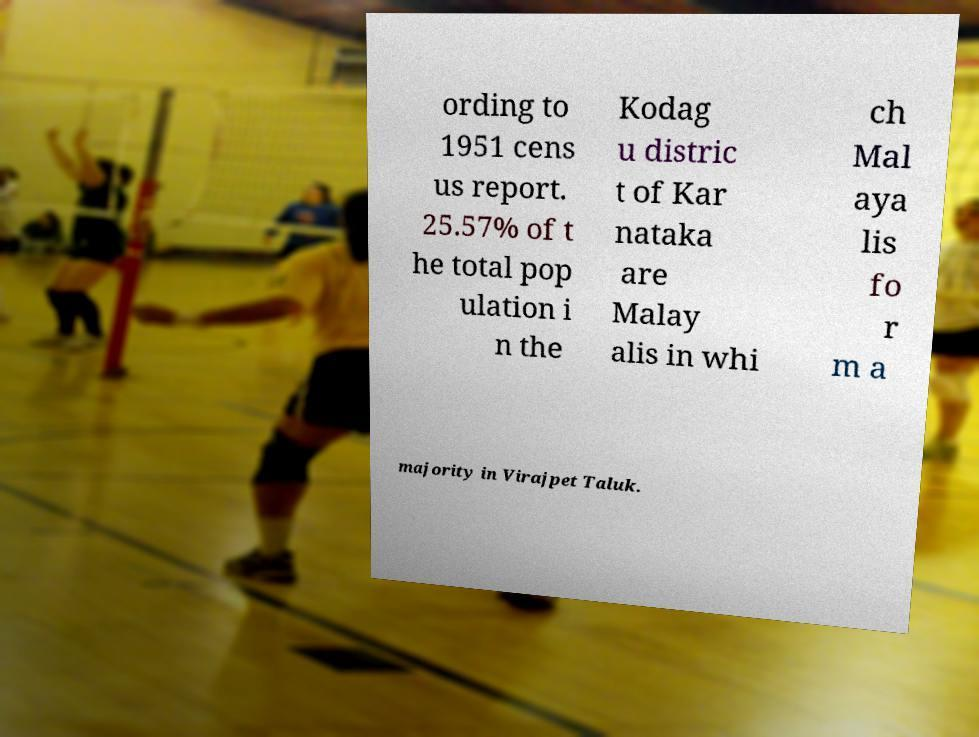Can you read and provide the text displayed in the image?This photo seems to have some interesting text. Can you extract and type it out for me? ording to 1951 cens us report. 25.57% of t he total pop ulation i n the Kodag u distric t of Kar nataka are Malay alis in whi ch Mal aya lis fo r m a majority in Virajpet Taluk. 